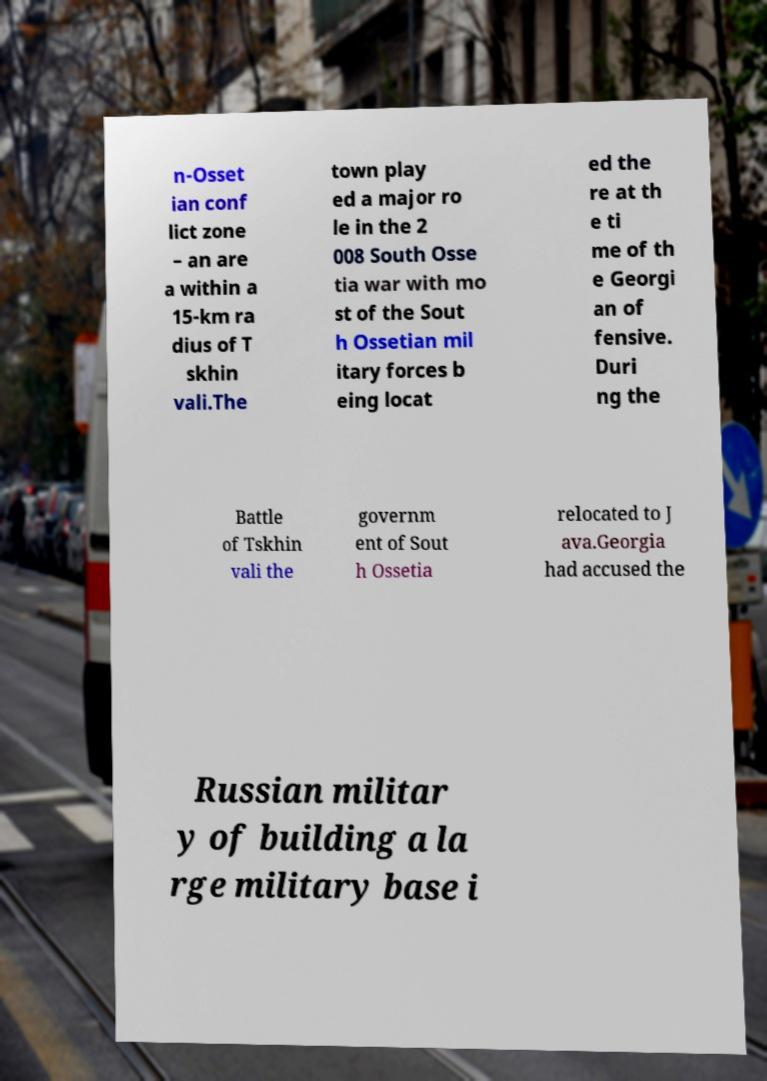Can you read and provide the text displayed in the image?This photo seems to have some interesting text. Can you extract and type it out for me? n-Osset ian conf lict zone – an are a within a 15-km ra dius of T skhin vali.The town play ed a major ro le in the 2 008 South Osse tia war with mo st of the Sout h Ossetian mil itary forces b eing locat ed the re at th e ti me of th e Georgi an of fensive. Duri ng the Battle of Tskhin vali the governm ent of Sout h Ossetia relocated to J ava.Georgia had accused the Russian militar y of building a la rge military base i 